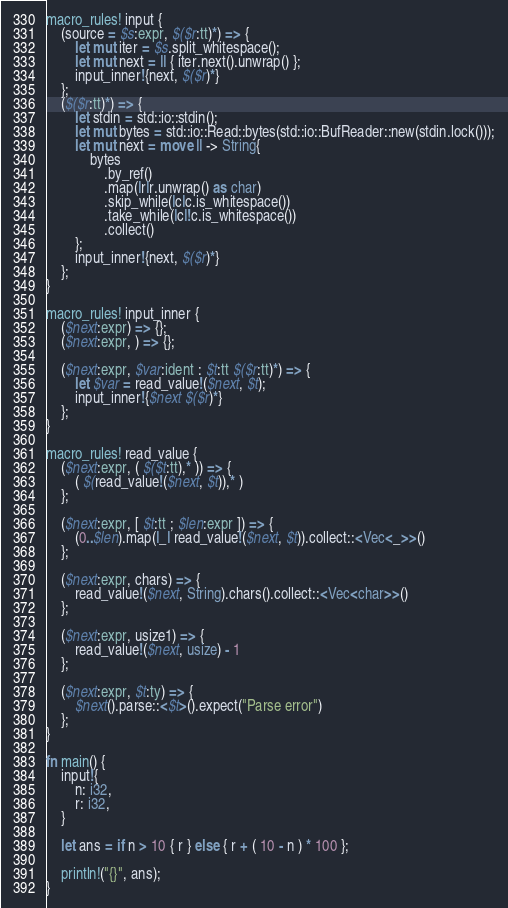Convert code to text. <code><loc_0><loc_0><loc_500><loc_500><_Rust_>macro_rules! input {
    (source = $s:expr, $($r:tt)*) => {
        let mut iter = $s.split_whitespace();
        let mut next = || { iter.next().unwrap() };
        input_inner!{next, $($r)*}
    };
    ($($r:tt)*) => {
        let stdin = std::io::stdin();
        let mut bytes = std::io::Read::bytes(std::io::BufReader::new(stdin.lock()));
        let mut next = move || -> String{
            bytes
                .by_ref()
                .map(|r|r.unwrap() as char)
                .skip_while(|c|c.is_whitespace())
                .take_while(|c|!c.is_whitespace())
                .collect()
        };
        input_inner!{next, $($r)*}
    };
}

macro_rules! input_inner {
    ($next:expr) => {};
    ($next:expr, ) => {};

    ($next:expr, $var:ident : $t:tt $($r:tt)*) => {
        let $var = read_value!($next, $t);
        input_inner!{$next $($r)*}
    };
}

macro_rules! read_value {
    ($next:expr, ( $($t:tt),* )) => {
        ( $(read_value!($next, $t)),* )
    };

    ($next:expr, [ $t:tt ; $len:expr ]) => {
        (0..$len).map(|_| read_value!($next, $t)).collect::<Vec<_>>()
    };

    ($next:expr, chars) => {
        read_value!($next, String).chars().collect::<Vec<char>>()
    };

    ($next:expr, usize1) => {
        read_value!($next, usize) - 1
    };

    ($next:expr, $t:ty) => {
        $next().parse::<$t>().expect("Parse error")
    };
}

fn main() {
    input!{
        n: i32,
        r: i32,
    }

    let ans = if n > 10 { r } else { r + ( 10 - n ) * 100 };

    println!("{}", ans);
}
</code> 